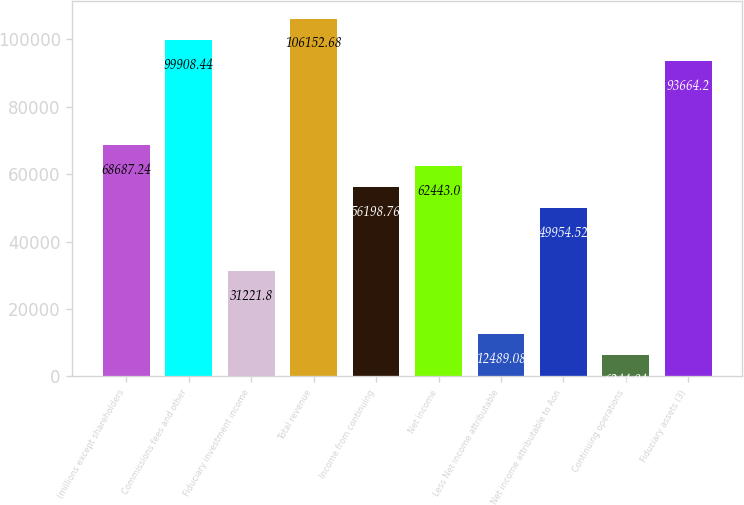<chart> <loc_0><loc_0><loc_500><loc_500><bar_chart><fcel>(millions except shareholders<fcel>Commissions fees and other<fcel>Fiduciary investment income<fcel>Total revenue<fcel>Income from continuing<fcel>Net income<fcel>Less Net income attributable<fcel>Net income attributable to Aon<fcel>Continuing operations<fcel>Fiduciary assets (3)<nl><fcel>68687.2<fcel>99908.4<fcel>31221.8<fcel>106153<fcel>56198.8<fcel>62443<fcel>12489.1<fcel>49954.5<fcel>6244.84<fcel>93664.2<nl></chart> 